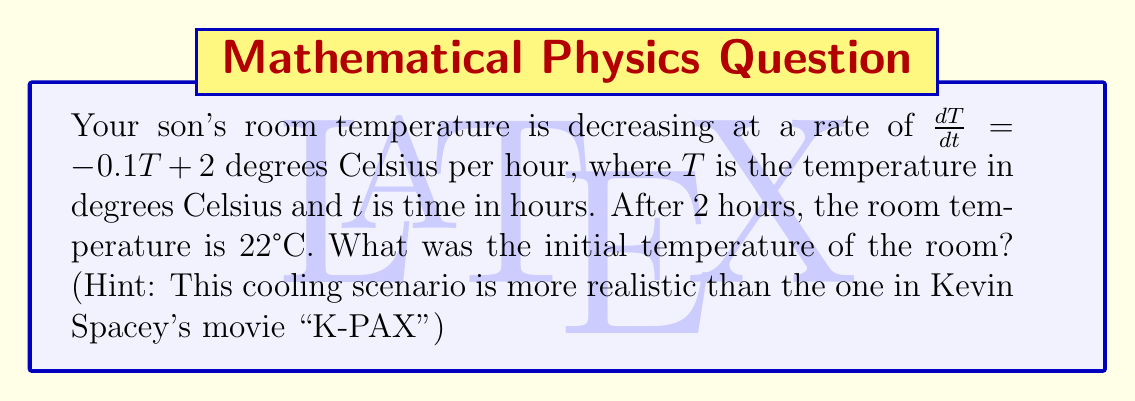What is the answer to this math problem? 1) The given differential equation is $\frac{dT}{dt} = -0.1T + 2$

2) This is a first-order linear differential equation. The general solution is:

   $$T(t) = 20 + Ce^{-0.1t}$$

   where $C$ is a constant to be determined.

3) We know that after 2 hours, $T(2) = 22$. Let's substitute this:

   $$22 = 20 + Ce^{-0.1(2)}$$

4) Simplify:
   $$22 = 20 + Ce^{-0.2}$$
   $$2 = Ce^{-0.2}$$

5) Solve for $C$:
   $$C = 2e^{0.2} \approx 2.4428$$

6) Now we have the specific solution:
   $$T(t) = 20 + 2.4428e^{-0.1t}$$

7) To find the initial temperature, we evaluate $T(0)$:
   $$T(0) = 20 + 2.4428e^{-0.1(0)} = 20 + 2.4428 = 22.4428$$

Therefore, the initial temperature was approximately 22.44°C.
Answer: 22.44°C 